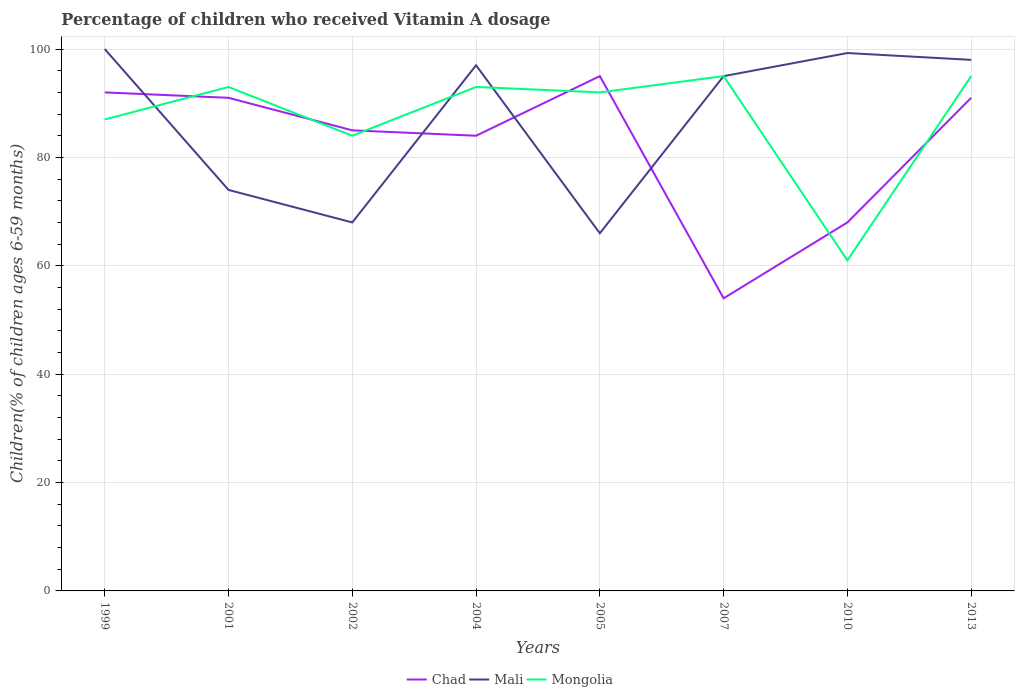Does the line corresponding to Chad intersect with the line corresponding to Mali?
Make the answer very short. Yes. Is the number of lines equal to the number of legend labels?
Provide a short and direct response. Yes. Across all years, what is the maximum percentage of children who received Vitamin A dosage in Mali?
Offer a very short reply. 66. In which year was the percentage of children who received Vitamin A dosage in Mali maximum?
Keep it short and to the point. 2005. Is the percentage of children who received Vitamin A dosage in Chad strictly greater than the percentage of children who received Vitamin A dosage in Mongolia over the years?
Your response must be concise. No. How many lines are there?
Ensure brevity in your answer.  3. Are the values on the major ticks of Y-axis written in scientific E-notation?
Give a very brief answer. No. Does the graph contain any zero values?
Your response must be concise. No. How many legend labels are there?
Provide a short and direct response. 3. How are the legend labels stacked?
Provide a short and direct response. Horizontal. What is the title of the graph?
Provide a succinct answer. Percentage of children who received Vitamin A dosage. Does "Tonga" appear as one of the legend labels in the graph?
Offer a terse response. No. What is the label or title of the X-axis?
Provide a succinct answer. Years. What is the label or title of the Y-axis?
Your response must be concise. Children(% of children ages 6-59 months). What is the Children(% of children ages 6-59 months) of Chad in 1999?
Make the answer very short. 92. What is the Children(% of children ages 6-59 months) of Mali in 1999?
Keep it short and to the point. 100. What is the Children(% of children ages 6-59 months) of Chad in 2001?
Your answer should be very brief. 91. What is the Children(% of children ages 6-59 months) in Mongolia in 2001?
Offer a very short reply. 93. What is the Children(% of children ages 6-59 months) of Chad in 2002?
Offer a very short reply. 85. What is the Children(% of children ages 6-59 months) in Mongolia in 2002?
Your answer should be very brief. 84. What is the Children(% of children ages 6-59 months) in Chad in 2004?
Your answer should be very brief. 84. What is the Children(% of children ages 6-59 months) of Mali in 2004?
Your answer should be compact. 97. What is the Children(% of children ages 6-59 months) of Mongolia in 2004?
Your answer should be very brief. 93. What is the Children(% of children ages 6-59 months) in Chad in 2005?
Your answer should be very brief. 95. What is the Children(% of children ages 6-59 months) of Mongolia in 2005?
Your answer should be compact. 92. What is the Children(% of children ages 6-59 months) in Mali in 2007?
Provide a succinct answer. 95. What is the Children(% of children ages 6-59 months) of Mali in 2010?
Your response must be concise. 99.26. What is the Children(% of children ages 6-59 months) of Mongolia in 2010?
Provide a succinct answer. 61. What is the Children(% of children ages 6-59 months) of Chad in 2013?
Your answer should be compact. 91. What is the Children(% of children ages 6-59 months) of Mali in 2013?
Offer a very short reply. 98. Across all years, what is the maximum Children(% of children ages 6-59 months) in Mali?
Offer a very short reply. 100. Across all years, what is the minimum Children(% of children ages 6-59 months) in Chad?
Offer a terse response. 54. Across all years, what is the minimum Children(% of children ages 6-59 months) in Mali?
Your answer should be very brief. 66. Across all years, what is the minimum Children(% of children ages 6-59 months) in Mongolia?
Keep it short and to the point. 61. What is the total Children(% of children ages 6-59 months) in Chad in the graph?
Your answer should be compact. 660. What is the total Children(% of children ages 6-59 months) of Mali in the graph?
Offer a terse response. 697.26. What is the total Children(% of children ages 6-59 months) in Mongolia in the graph?
Offer a very short reply. 700. What is the difference between the Children(% of children ages 6-59 months) in Chad in 1999 and that in 2002?
Offer a very short reply. 7. What is the difference between the Children(% of children ages 6-59 months) of Mongolia in 1999 and that in 2002?
Your answer should be very brief. 3. What is the difference between the Children(% of children ages 6-59 months) in Chad in 1999 and that in 2004?
Your response must be concise. 8. What is the difference between the Children(% of children ages 6-59 months) of Mali in 1999 and that in 2004?
Your answer should be very brief. 3. What is the difference between the Children(% of children ages 6-59 months) in Mali in 1999 and that in 2005?
Offer a terse response. 34. What is the difference between the Children(% of children ages 6-59 months) of Mongolia in 1999 and that in 2005?
Offer a terse response. -5. What is the difference between the Children(% of children ages 6-59 months) in Mali in 1999 and that in 2010?
Give a very brief answer. 0.74. What is the difference between the Children(% of children ages 6-59 months) of Chad in 1999 and that in 2013?
Offer a terse response. 1. What is the difference between the Children(% of children ages 6-59 months) of Mali in 1999 and that in 2013?
Ensure brevity in your answer.  2. What is the difference between the Children(% of children ages 6-59 months) of Mongolia in 1999 and that in 2013?
Offer a terse response. -8. What is the difference between the Children(% of children ages 6-59 months) in Mali in 2001 and that in 2002?
Offer a very short reply. 6. What is the difference between the Children(% of children ages 6-59 months) in Mongolia in 2001 and that in 2002?
Provide a succinct answer. 9. What is the difference between the Children(% of children ages 6-59 months) in Mongolia in 2001 and that in 2004?
Offer a terse response. 0. What is the difference between the Children(% of children ages 6-59 months) of Chad in 2001 and that in 2007?
Offer a very short reply. 37. What is the difference between the Children(% of children ages 6-59 months) in Chad in 2001 and that in 2010?
Your answer should be very brief. 23. What is the difference between the Children(% of children ages 6-59 months) in Mali in 2001 and that in 2010?
Ensure brevity in your answer.  -25.26. What is the difference between the Children(% of children ages 6-59 months) in Mongolia in 2001 and that in 2013?
Ensure brevity in your answer.  -2. What is the difference between the Children(% of children ages 6-59 months) of Mongolia in 2002 and that in 2004?
Offer a terse response. -9. What is the difference between the Children(% of children ages 6-59 months) of Chad in 2002 and that in 2005?
Your answer should be very brief. -10. What is the difference between the Children(% of children ages 6-59 months) in Mali in 2002 and that in 2005?
Ensure brevity in your answer.  2. What is the difference between the Children(% of children ages 6-59 months) of Mongolia in 2002 and that in 2005?
Offer a very short reply. -8. What is the difference between the Children(% of children ages 6-59 months) of Chad in 2002 and that in 2007?
Offer a terse response. 31. What is the difference between the Children(% of children ages 6-59 months) of Chad in 2002 and that in 2010?
Your response must be concise. 17. What is the difference between the Children(% of children ages 6-59 months) of Mali in 2002 and that in 2010?
Make the answer very short. -31.26. What is the difference between the Children(% of children ages 6-59 months) of Mongolia in 2002 and that in 2010?
Provide a succinct answer. 23. What is the difference between the Children(% of children ages 6-59 months) of Mali in 2002 and that in 2013?
Keep it short and to the point. -30. What is the difference between the Children(% of children ages 6-59 months) in Mongolia in 2002 and that in 2013?
Keep it short and to the point. -11. What is the difference between the Children(% of children ages 6-59 months) in Chad in 2004 and that in 2005?
Offer a terse response. -11. What is the difference between the Children(% of children ages 6-59 months) in Mongolia in 2004 and that in 2005?
Make the answer very short. 1. What is the difference between the Children(% of children ages 6-59 months) of Chad in 2004 and that in 2007?
Provide a short and direct response. 30. What is the difference between the Children(% of children ages 6-59 months) of Chad in 2004 and that in 2010?
Offer a terse response. 16. What is the difference between the Children(% of children ages 6-59 months) of Mali in 2004 and that in 2010?
Give a very brief answer. -2.26. What is the difference between the Children(% of children ages 6-59 months) of Mongolia in 2004 and that in 2010?
Your answer should be compact. 32. What is the difference between the Children(% of children ages 6-59 months) of Mali in 2004 and that in 2013?
Offer a very short reply. -1. What is the difference between the Children(% of children ages 6-59 months) of Chad in 2005 and that in 2007?
Ensure brevity in your answer.  41. What is the difference between the Children(% of children ages 6-59 months) of Mali in 2005 and that in 2007?
Your answer should be very brief. -29. What is the difference between the Children(% of children ages 6-59 months) in Mongolia in 2005 and that in 2007?
Keep it short and to the point. -3. What is the difference between the Children(% of children ages 6-59 months) of Chad in 2005 and that in 2010?
Provide a succinct answer. 27. What is the difference between the Children(% of children ages 6-59 months) of Mali in 2005 and that in 2010?
Offer a terse response. -33.26. What is the difference between the Children(% of children ages 6-59 months) of Chad in 2005 and that in 2013?
Give a very brief answer. 4. What is the difference between the Children(% of children ages 6-59 months) of Mali in 2005 and that in 2013?
Provide a short and direct response. -32. What is the difference between the Children(% of children ages 6-59 months) in Chad in 2007 and that in 2010?
Make the answer very short. -14. What is the difference between the Children(% of children ages 6-59 months) of Mali in 2007 and that in 2010?
Ensure brevity in your answer.  -4.26. What is the difference between the Children(% of children ages 6-59 months) of Chad in 2007 and that in 2013?
Keep it short and to the point. -37. What is the difference between the Children(% of children ages 6-59 months) in Mongolia in 2007 and that in 2013?
Provide a short and direct response. 0. What is the difference between the Children(% of children ages 6-59 months) of Chad in 2010 and that in 2013?
Your response must be concise. -23. What is the difference between the Children(% of children ages 6-59 months) in Mali in 2010 and that in 2013?
Give a very brief answer. 1.26. What is the difference between the Children(% of children ages 6-59 months) of Mongolia in 2010 and that in 2013?
Your response must be concise. -34. What is the difference between the Children(% of children ages 6-59 months) of Chad in 1999 and the Children(% of children ages 6-59 months) of Mali in 2001?
Your response must be concise. 18. What is the difference between the Children(% of children ages 6-59 months) of Mali in 1999 and the Children(% of children ages 6-59 months) of Mongolia in 2001?
Your answer should be compact. 7. What is the difference between the Children(% of children ages 6-59 months) in Chad in 1999 and the Children(% of children ages 6-59 months) in Mali in 2002?
Keep it short and to the point. 24. What is the difference between the Children(% of children ages 6-59 months) in Chad in 1999 and the Children(% of children ages 6-59 months) in Mali in 2004?
Your answer should be compact. -5. What is the difference between the Children(% of children ages 6-59 months) in Mali in 1999 and the Children(% of children ages 6-59 months) in Mongolia in 2004?
Provide a short and direct response. 7. What is the difference between the Children(% of children ages 6-59 months) in Mali in 1999 and the Children(% of children ages 6-59 months) in Mongolia in 2005?
Offer a terse response. 8. What is the difference between the Children(% of children ages 6-59 months) of Chad in 1999 and the Children(% of children ages 6-59 months) of Mali in 2010?
Provide a succinct answer. -7.26. What is the difference between the Children(% of children ages 6-59 months) of Chad in 1999 and the Children(% of children ages 6-59 months) of Mongolia in 2010?
Your response must be concise. 31. What is the difference between the Children(% of children ages 6-59 months) in Chad in 1999 and the Children(% of children ages 6-59 months) in Mongolia in 2013?
Your response must be concise. -3. What is the difference between the Children(% of children ages 6-59 months) in Chad in 2001 and the Children(% of children ages 6-59 months) in Mali in 2002?
Offer a very short reply. 23. What is the difference between the Children(% of children ages 6-59 months) in Chad in 2001 and the Children(% of children ages 6-59 months) in Mali in 2004?
Offer a terse response. -6. What is the difference between the Children(% of children ages 6-59 months) in Chad in 2001 and the Children(% of children ages 6-59 months) in Mongolia in 2004?
Provide a succinct answer. -2. What is the difference between the Children(% of children ages 6-59 months) in Mali in 2001 and the Children(% of children ages 6-59 months) in Mongolia in 2004?
Provide a succinct answer. -19. What is the difference between the Children(% of children ages 6-59 months) in Chad in 2001 and the Children(% of children ages 6-59 months) in Mongolia in 2005?
Your response must be concise. -1. What is the difference between the Children(% of children ages 6-59 months) in Mali in 2001 and the Children(% of children ages 6-59 months) in Mongolia in 2005?
Ensure brevity in your answer.  -18. What is the difference between the Children(% of children ages 6-59 months) in Mali in 2001 and the Children(% of children ages 6-59 months) in Mongolia in 2007?
Your answer should be very brief. -21. What is the difference between the Children(% of children ages 6-59 months) in Chad in 2001 and the Children(% of children ages 6-59 months) in Mali in 2010?
Ensure brevity in your answer.  -8.26. What is the difference between the Children(% of children ages 6-59 months) in Chad in 2001 and the Children(% of children ages 6-59 months) in Mongolia in 2013?
Offer a terse response. -4. What is the difference between the Children(% of children ages 6-59 months) in Chad in 2002 and the Children(% of children ages 6-59 months) in Mongolia in 2005?
Your response must be concise. -7. What is the difference between the Children(% of children ages 6-59 months) of Mali in 2002 and the Children(% of children ages 6-59 months) of Mongolia in 2007?
Make the answer very short. -27. What is the difference between the Children(% of children ages 6-59 months) of Chad in 2002 and the Children(% of children ages 6-59 months) of Mali in 2010?
Your answer should be very brief. -14.26. What is the difference between the Children(% of children ages 6-59 months) of Chad in 2002 and the Children(% of children ages 6-59 months) of Mongolia in 2010?
Your response must be concise. 24. What is the difference between the Children(% of children ages 6-59 months) in Chad in 2002 and the Children(% of children ages 6-59 months) in Mongolia in 2013?
Make the answer very short. -10. What is the difference between the Children(% of children ages 6-59 months) of Chad in 2004 and the Children(% of children ages 6-59 months) of Mongolia in 2005?
Your response must be concise. -8. What is the difference between the Children(% of children ages 6-59 months) in Mali in 2004 and the Children(% of children ages 6-59 months) in Mongolia in 2007?
Offer a terse response. 2. What is the difference between the Children(% of children ages 6-59 months) of Chad in 2004 and the Children(% of children ages 6-59 months) of Mali in 2010?
Offer a very short reply. -15.26. What is the difference between the Children(% of children ages 6-59 months) in Mali in 2004 and the Children(% of children ages 6-59 months) in Mongolia in 2010?
Your answer should be compact. 36. What is the difference between the Children(% of children ages 6-59 months) of Chad in 2004 and the Children(% of children ages 6-59 months) of Mongolia in 2013?
Provide a succinct answer. -11. What is the difference between the Children(% of children ages 6-59 months) of Chad in 2005 and the Children(% of children ages 6-59 months) of Mali in 2007?
Your response must be concise. 0. What is the difference between the Children(% of children ages 6-59 months) in Chad in 2005 and the Children(% of children ages 6-59 months) in Mali in 2010?
Offer a terse response. -4.26. What is the difference between the Children(% of children ages 6-59 months) in Chad in 2005 and the Children(% of children ages 6-59 months) in Mongolia in 2013?
Offer a very short reply. 0. What is the difference between the Children(% of children ages 6-59 months) in Mali in 2005 and the Children(% of children ages 6-59 months) in Mongolia in 2013?
Provide a short and direct response. -29. What is the difference between the Children(% of children ages 6-59 months) of Chad in 2007 and the Children(% of children ages 6-59 months) of Mali in 2010?
Your answer should be very brief. -45.26. What is the difference between the Children(% of children ages 6-59 months) of Chad in 2007 and the Children(% of children ages 6-59 months) of Mongolia in 2010?
Provide a short and direct response. -7. What is the difference between the Children(% of children ages 6-59 months) of Chad in 2007 and the Children(% of children ages 6-59 months) of Mali in 2013?
Provide a succinct answer. -44. What is the difference between the Children(% of children ages 6-59 months) in Chad in 2007 and the Children(% of children ages 6-59 months) in Mongolia in 2013?
Offer a terse response. -41. What is the difference between the Children(% of children ages 6-59 months) in Chad in 2010 and the Children(% of children ages 6-59 months) in Mongolia in 2013?
Your answer should be compact. -27. What is the difference between the Children(% of children ages 6-59 months) of Mali in 2010 and the Children(% of children ages 6-59 months) of Mongolia in 2013?
Give a very brief answer. 4.26. What is the average Children(% of children ages 6-59 months) of Chad per year?
Offer a very short reply. 82.5. What is the average Children(% of children ages 6-59 months) of Mali per year?
Keep it short and to the point. 87.16. What is the average Children(% of children ages 6-59 months) of Mongolia per year?
Provide a succinct answer. 87.5. In the year 1999, what is the difference between the Children(% of children ages 6-59 months) of Chad and Children(% of children ages 6-59 months) of Mongolia?
Offer a very short reply. 5. In the year 1999, what is the difference between the Children(% of children ages 6-59 months) in Mali and Children(% of children ages 6-59 months) in Mongolia?
Offer a terse response. 13. In the year 2001, what is the difference between the Children(% of children ages 6-59 months) of Chad and Children(% of children ages 6-59 months) of Mali?
Make the answer very short. 17. In the year 2002, what is the difference between the Children(% of children ages 6-59 months) of Mali and Children(% of children ages 6-59 months) of Mongolia?
Make the answer very short. -16. In the year 2004, what is the difference between the Children(% of children ages 6-59 months) of Chad and Children(% of children ages 6-59 months) of Mali?
Give a very brief answer. -13. In the year 2004, what is the difference between the Children(% of children ages 6-59 months) in Chad and Children(% of children ages 6-59 months) in Mongolia?
Provide a short and direct response. -9. In the year 2004, what is the difference between the Children(% of children ages 6-59 months) in Mali and Children(% of children ages 6-59 months) in Mongolia?
Give a very brief answer. 4. In the year 2005, what is the difference between the Children(% of children ages 6-59 months) in Chad and Children(% of children ages 6-59 months) in Mali?
Offer a terse response. 29. In the year 2005, what is the difference between the Children(% of children ages 6-59 months) in Chad and Children(% of children ages 6-59 months) in Mongolia?
Your answer should be very brief. 3. In the year 2007, what is the difference between the Children(% of children ages 6-59 months) of Chad and Children(% of children ages 6-59 months) of Mali?
Your response must be concise. -41. In the year 2007, what is the difference between the Children(% of children ages 6-59 months) in Chad and Children(% of children ages 6-59 months) in Mongolia?
Your answer should be compact. -41. In the year 2010, what is the difference between the Children(% of children ages 6-59 months) in Chad and Children(% of children ages 6-59 months) in Mali?
Offer a very short reply. -31.26. In the year 2010, what is the difference between the Children(% of children ages 6-59 months) in Chad and Children(% of children ages 6-59 months) in Mongolia?
Your answer should be very brief. 7. In the year 2010, what is the difference between the Children(% of children ages 6-59 months) of Mali and Children(% of children ages 6-59 months) of Mongolia?
Offer a very short reply. 38.26. In the year 2013, what is the difference between the Children(% of children ages 6-59 months) in Chad and Children(% of children ages 6-59 months) in Mali?
Your answer should be very brief. -7. What is the ratio of the Children(% of children ages 6-59 months) of Mali in 1999 to that in 2001?
Make the answer very short. 1.35. What is the ratio of the Children(% of children ages 6-59 months) in Mongolia in 1999 to that in 2001?
Provide a short and direct response. 0.94. What is the ratio of the Children(% of children ages 6-59 months) in Chad in 1999 to that in 2002?
Provide a succinct answer. 1.08. What is the ratio of the Children(% of children ages 6-59 months) of Mali in 1999 to that in 2002?
Your response must be concise. 1.47. What is the ratio of the Children(% of children ages 6-59 months) in Mongolia in 1999 to that in 2002?
Ensure brevity in your answer.  1.04. What is the ratio of the Children(% of children ages 6-59 months) in Chad in 1999 to that in 2004?
Give a very brief answer. 1.1. What is the ratio of the Children(% of children ages 6-59 months) of Mali in 1999 to that in 2004?
Offer a terse response. 1.03. What is the ratio of the Children(% of children ages 6-59 months) of Mongolia in 1999 to that in 2004?
Your answer should be very brief. 0.94. What is the ratio of the Children(% of children ages 6-59 months) in Chad in 1999 to that in 2005?
Your answer should be very brief. 0.97. What is the ratio of the Children(% of children ages 6-59 months) of Mali in 1999 to that in 2005?
Ensure brevity in your answer.  1.52. What is the ratio of the Children(% of children ages 6-59 months) of Mongolia in 1999 to that in 2005?
Offer a terse response. 0.95. What is the ratio of the Children(% of children ages 6-59 months) in Chad in 1999 to that in 2007?
Your answer should be compact. 1.7. What is the ratio of the Children(% of children ages 6-59 months) in Mali in 1999 to that in 2007?
Give a very brief answer. 1.05. What is the ratio of the Children(% of children ages 6-59 months) of Mongolia in 1999 to that in 2007?
Your response must be concise. 0.92. What is the ratio of the Children(% of children ages 6-59 months) in Chad in 1999 to that in 2010?
Give a very brief answer. 1.35. What is the ratio of the Children(% of children ages 6-59 months) in Mali in 1999 to that in 2010?
Offer a terse response. 1.01. What is the ratio of the Children(% of children ages 6-59 months) in Mongolia in 1999 to that in 2010?
Offer a very short reply. 1.43. What is the ratio of the Children(% of children ages 6-59 months) in Mali in 1999 to that in 2013?
Give a very brief answer. 1.02. What is the ratio of the Children(% of children ages 6-59 months) in Mongolia in 1999 to that in 2013?
Your response must be concise. 0.92. What is the ratio of the Children(% of children ages 6-59 months) in Chad in 2001 to that in 2002?
Provide a succinct answer. 1.07. What is the ratio of the Children(% of children ages 6-59 months) of Mali in 2001 to that in 2002?
Provide a short and direct response. 1.09. What is the ratio of the Children(% of children ages 6-59 months) in Mongolia in 2001 to that in 2002?
Give a very brief answer. 1.11. What is the ratio of the Children(% of children ages 6-59 months) in Mali in 2001 to that in 2004?
Ensure brevity in your answer.  0.76. What is the ratio of the Children(% of children ages 6-59 months) in Mongolia in 2001 to that in 2004?
Your answer should be very brief. 1. What is the ratio of the Children(% of children ages 6-59 months) of Chad in 2001 to that in 2005?
Give a very brief answer. 0.96. What is the ratio of the Children(% of children ages 6-59 months) of Mali in 2001 to that in 2005?
Your answer should be compact. 1.12. What is the ratio of the Children(% of children ages 6-59 months) of Mongolia in 2001 to that in 2005?
Ensure brevity in your answer.  1.01. What is the ratio of the Children(% of children ages 6-59 months) in Chad in 2001 to that in 2007?
Your response must be concise. 1.69. What is the ratio of the Children(% of children ages 6-59 months) in Mali in 2001 to that in 2007?
Keep it short and to the point. 0.78. What is the ratio of the Children(% of children ages 6-59 months) of Mongolia in 2001 to that in 2007?
Your answer should be very brief. 0.98. What is the ratio of the Children(% of children ages 6-59 months) in Chad in 2001 to that in 2010?
Give a very brief answer. 1.34. What is the ratio of the Children(% of children ages 6-59 months) in Mali in 2001 to that in 2010?
Your answer should be compact. 0.75. What is the ratio of the Children(% of children ages 6-59 months) of Mongolia in 2001 to that in 2010?
Give a very brief answer. 1.52. What is the ratio of the Children(% of children ages 6-59 months) of Chad in 2001 to that in 2013?
Ensure brevity in your answer.  1. What is the ratio of the Children(% of children ages 6-59 months) of Mali in 2001 to that in 2013?
Keep it short and to the point. 0.76. What is the ratio of the Children(% of children ages 6-59 months) of Mongolia in 2001 to that in 2013?
Keep it short and to the point. 0.98. What is the ratio of the Children(% of children ages 6-59 months) of Chad in 2002 to that in 2004?
Your answer should be very brief. 1.01. What is the ratio of the Children(% of children ages 6-59 months) of Mali in 2002 to that in 2004?
Provide a short and direct response. 0.7. What is the ratio of the Children(% of children ages 6-59 months) in Mongolia in 2002 to that in 2004?
Your answer should be very brief. 0.9. What is the ratio of the Children(% of children ages 6-59 months) in Chad in 2002 to that in 2005?
Give a very brief answer. 0.89. What is the ratio of the Children(% of children ages 6-59 months) of Mali in 2002 to that in 2005?
Keep it short and to the point. 1.03. What is the ratio of the Children(% of children ages 6-59 months) of Mongolia in 2002 to that in 2005?
Give a very brief answer. 0.91. What is the ratio of the Children(% of children ages 6-59 months) of Chad in 2002 to that in 2007?
Keep it short and to the point. 1.57. What is the ratio of the Children(% of children ages 6-59 months) of Mali in 2002 to that in 2007?
Ensure brevity in your answer.  0.72. What is the ratio of the Children(% of children ages 6-59 months) of Mongolia in 2002 to that in 2007?
Make the answer very short. 0.88. What is the ratio of the Children(% of children ages 6-59 months) in Chad in 2002 to that in 2010?
Offer a very short reply. 1.25. What is the ratio of the Children(% of children ages 6-59 months) of Mali in 2002 to that in 2010?
Offer a very short reply. 0.69. What is the ratio of the Children(% of children ages 6-59 months) of Mongolia in 2002 to that in 2010?
Provide a short and direct response. 1.38. What is the ratio of the Children(% of children ages 6-59 months) of Chad in 2002 to that in 2013?
Offer a terse response. 0.93. What is the ratio of the Children(% of children ages 6-59 months) of Mali in 2002 to that in 2013?
Ensure brevity in your answer.  0.69. What is the ratio of the Children(% of children ages 6-59 months) in Mongolia in 2002 to that in 2013?
Give a very brief answer. 0.88. What is the ratio of the Children(% of children ages 6-59 months) of Chad in 2004 to that in 2005?
Make the answer very short. 0.88. What is the ratio of the Children(% of children ages 6-59 months) in Mali in 2004 to that in 2005?
Your answer should be compact. 1.47. What is the ratio of the Children(% of children ages 6-59 months) of Mongolia in 2004 to that in 2005?
Offer a terse response. 1.01. What is the ratio of the Children(% of children ages 6-59 months) of Chad in 2004 to that in 2007?
Offer a terse response. 1.56. What is the ratio of the Children(% of children ages 6-59 months) in Mali in 2004 to that in 2007?
Ensure brevity in your answer.  1.02. What is the ratio of the Children(% of children ages 6-59 months) of Mongolia in 2004 to that in 2007?
Ensure brevity in your answer.  0.98. What is the ratio of the Children(% of children ages 6-59 months) in Chad in 2004 to that in 2010?
Provide a short and direct response. 1.24. What is the ratio of the Children(% of children ages 6-59 months) of Mali in 2004 to that in 2010?
Provide a short and direct response. 0.98. What is the ratio of the Children(% of children ages 6-59 months) in Mongolia in 2004 to that in 2010?
Offer a very short reply. 1.52. What is the ratio of the Children(% of children ages 6-59 months) of Mongolia in 2004 to that in 2013?
Keep it short and to the point. 0.98. What is the ratio of the Children(% of children ages 6-59 months) in Chad in 2005 to that in 2007?
Keep it short and to the point. 1.76. What is the ratio of the Children(% of children ages 6-59 months) of Mali in 2005 to that in 2007?
Provide a succinct answer. 0.69. What is the ratio of the Children(% of children ages 6-59 months) in Mongolia in 2005 to that in 2007?
Your answer should be compact. 0.97. What is the ratio of the Children(% of children ages 6-59 months) of Chad in 2005 to that in 2010?
Offer a very short reply. 1.4. What is the ratio of the Children(% of children ages 6-59 months) in Mali in 2005 to that in 2010?
Your answer should be very brief. 0.66. What is the ratio of the Children(% of children ages 6-59 months) in Mongolia in 2005 to that in 2010?
Offer a terse response. 1.51. What is the ratio of the Children(% of children ages 6-59 months) in Chad in 2005 to that in 2013?
Your answer should be very brief. 1.04. What is the ratio of the Children(% of children ages 6-59 months) of Mali in 2005 to that in 2013?
Your answer should be very brief. 0.67. What is the ratio of the Children(% of children ages 6-59 months) of Mongolia in 2005 to that in 2013?
Ensure brevity in your answer.  0.97. What is the ratio of the Children(% of children ages 6-59 months) in Chad in 2007 to that in 2010?
Make the answer very short. 0.79. What is the ratio of the Children(% of children ages 6-59 months) of Mongolia in 2007 to that in 2010?
Your answer should be compact. 1.56. What is the ratio of the Children(% of children ages 6-59 months) of Chad in 2007 to that in 2013?
Give a very brief answer. 0.59. What is the ratio of the Children(% of children ages 6-59 months) in Mali in 2007 to that in 2013?
Ensure brevity in your answer.  0.97. What is the ratio of the Children(% of children ages 6-59 months) in Mongolia in 2007 to that in 2013?
Your response must be concise. 1. What is the ratio of the Children(% of children ages 6-59 months) in Chad in 2010 to that in 2013?
Ensure brevity in your answer.  0.75. What is the ratio of the Children(% of children ages 6-59 months) of Mali in 2010 to that in 2013?
Your response must be concise. 1.01. What is the ratio of the Children(% of children ages 6-59 months) of Mongolia in 2010 to that in 2013?
Ensure brevity in your answer.  0.64. What is the difference between the highest and the second highest Children(% of children ages 6-59 months) in Chad?
Ensure brevity in your answer.  3. What is the difference between the highest and the second highest Children(% of children ages 6-59 months) in Mali?
Provide a short and direct response. 0.74. What is the difference between the highest and the second highest Children(% of children ages 6-59 months) of Mongolia?
Your response must be concise. 0. 